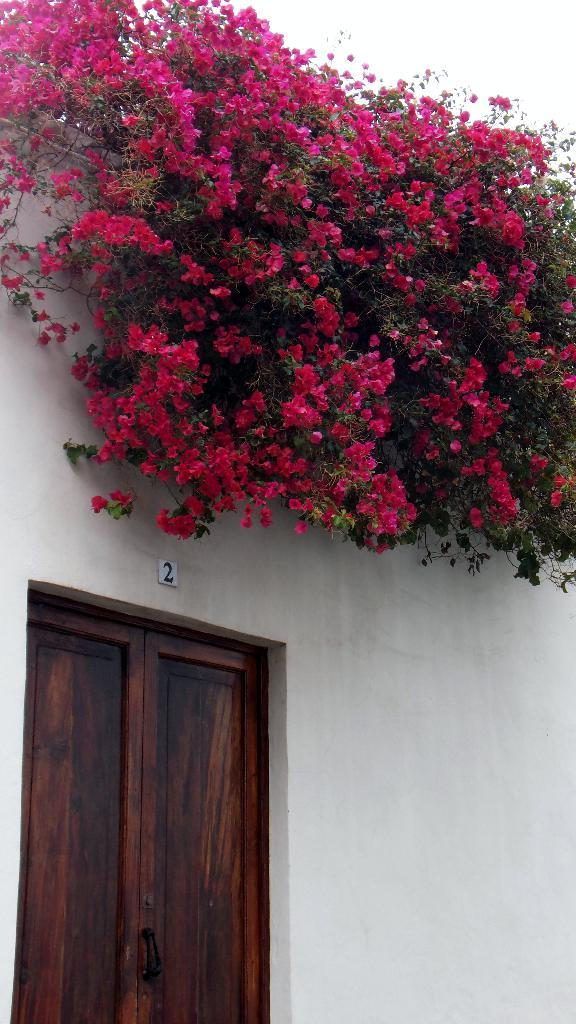What color are the flowers on the building in the image? The flowers on the building are pink. What color is the building on which the flowers are present? The building is white. What type of door can be seen in the image? There is a wooden door in the image. What type of produce is being sold on the street in the image? There is no street or produce visible in the image; it only features pink flowers on a white building and a wooden door. 